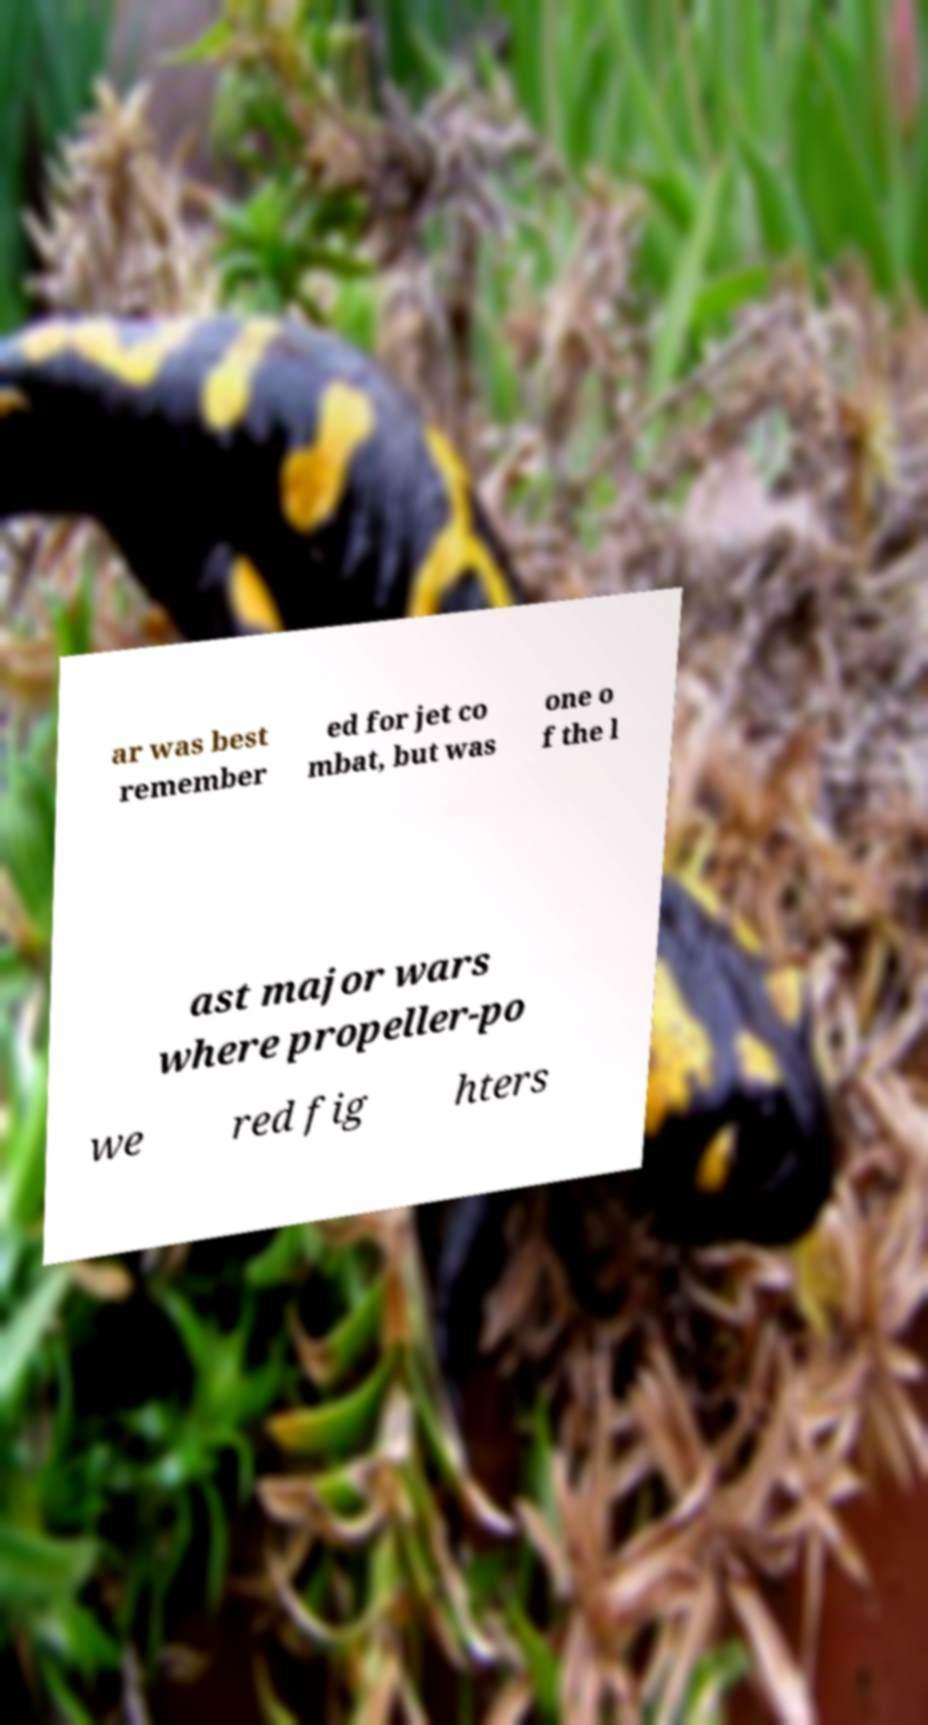Can you read and provide the text displayed in the image?This photo seems to have some interesting text. Can you extract and type it out for me? ar was best remember ed for jet co mbat, but was one o f the l ast major wars where propeller-po we red fig hters 